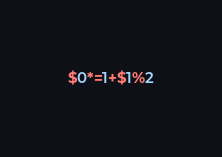Convert code to text. <code><loc_0><loc_0><loc_500><loc_500><_Awk_>$0*=1+$1%2</code> 